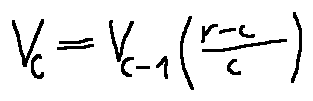Convert formula to latex. <formula><loc_0><loc_0><loc_500><loc_500>v _ { c } = v _ { c - 1 } ( \frac { r - c } { c } )</formula> 